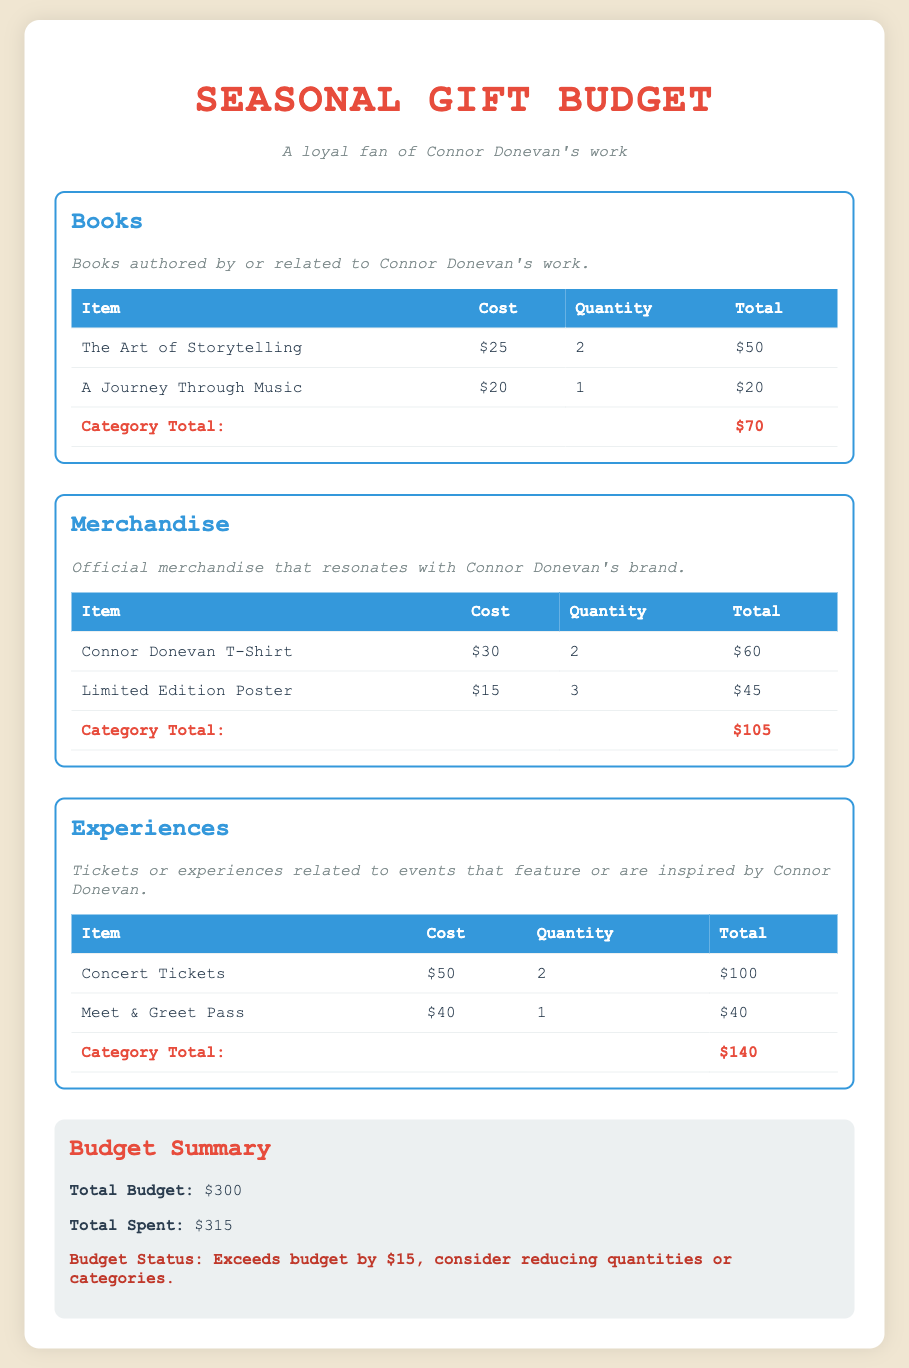what is the total budget? The total budget is a specified amount available for spending, which is listed in the document as $300.
Answer: $300 what is the total spent? The total spent reflects the actual amount used for purchases, calculated from the detailed items listed, which is $315.
Answer: $315 which book is priced at $20? To identify the book, we refer to the items under the Books category; it is noted that "A Journey Through Music" is priced at $20.
Answer: A Journey Through Music how many Connor Donevan T-Shirts are planned for purchase? The planned purchase quantity for Connor Donevan T-Shirts is shown in the Merchandise section, which states a quantity of 2.
Answer: 2 what is the total cost for experiences? The total cost for Experiences includes Concert Tickets and Meet & Greet Pass, leading to a sum total of $140.
Answer: $140 how much does a Limited Edition Poster cost? The cost of a Limited Edition Poster is shown in the Merchandise table, which indicates it costs $15.
Answer: $15 what does the budget status indicate? The budget status provides an assessment of the spending versus the budget, indicating that spending exceeds the budget by $15.
Answer: Exceeds budget by $15 how many different categories are listed in the budget? By counting the distinct sections presented in the document, including Books, Merchandise, and Experiences, we find there are 3 categories.
Answer: 3 what is the total quantity of books planned for purchase? The total quantity is calculated as the sum of quantities for all book items listed, which comes to 3 (2 + 1).
Answer: 3 